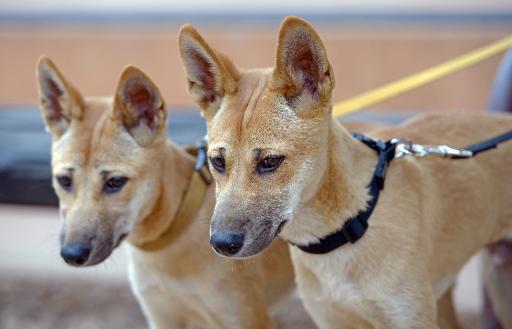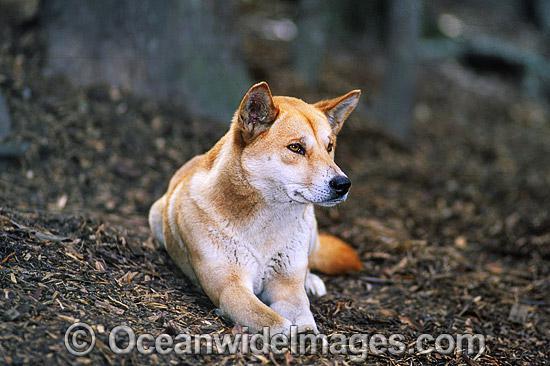The first image is the image on the left, the second image is the image on the right. Analyze the images presented: Is the assertion "A total of two canines are shown." valid? Answer yes or no. No. 